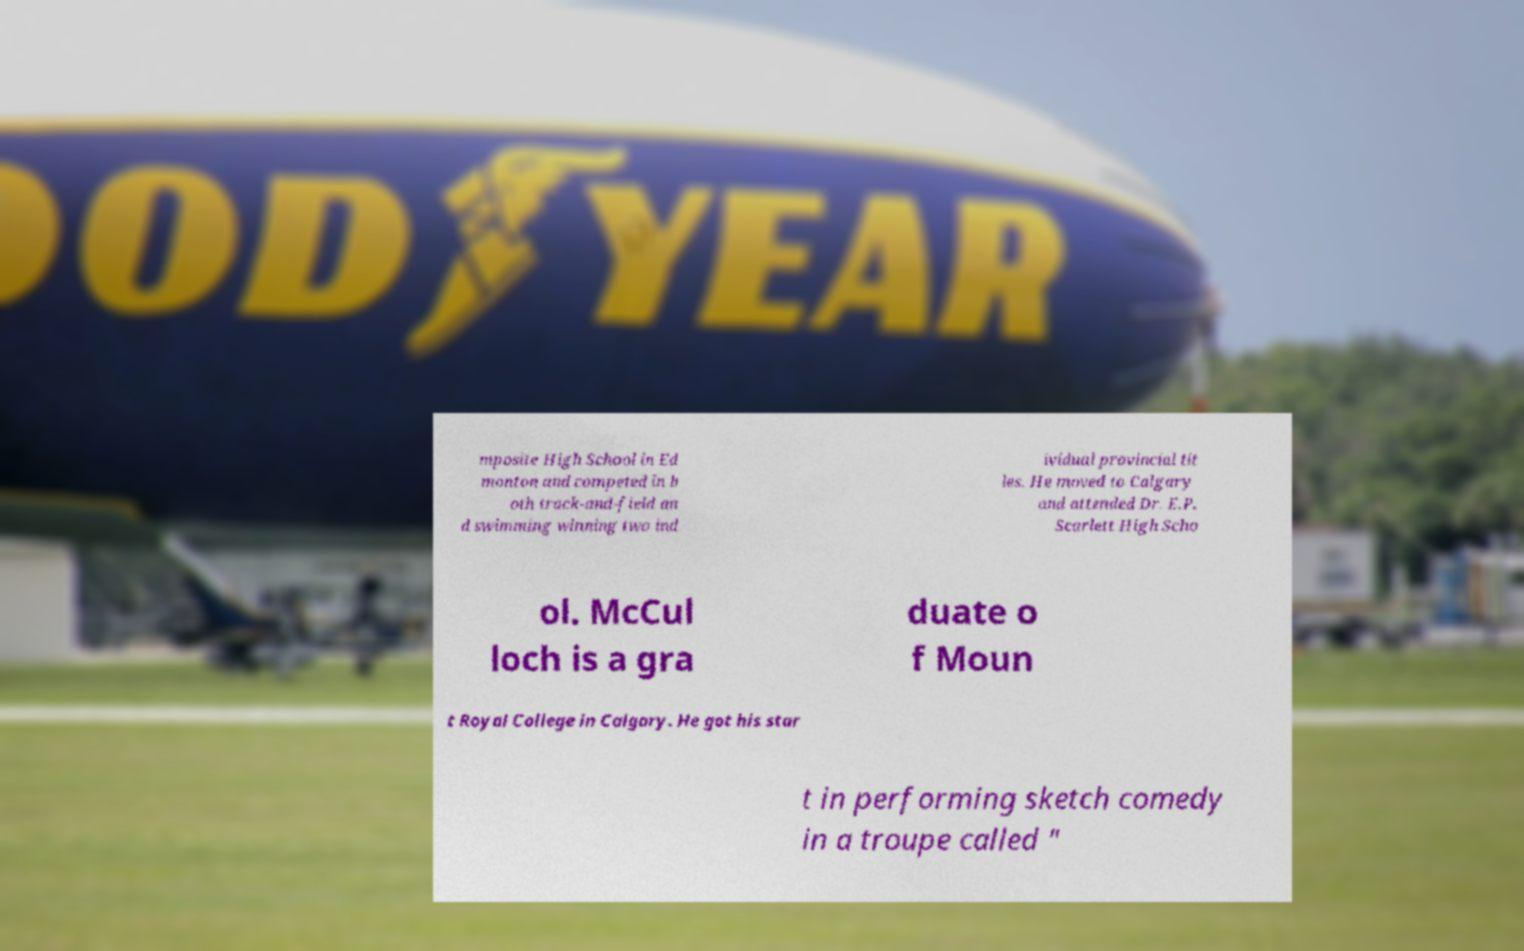Could you extract and type out the text from this image? mposite High School in Ed monton and competed in b oth track-and-field an d swimming winning two ind ividual provincial tit les. He moved to Calgary and attended Dr. E.P. Scarlett High Scho ol. McCul loch is a gra duate o f Moun t Royal College in Calgary. He got his star t in performing sketch comedy in a troupe called " 